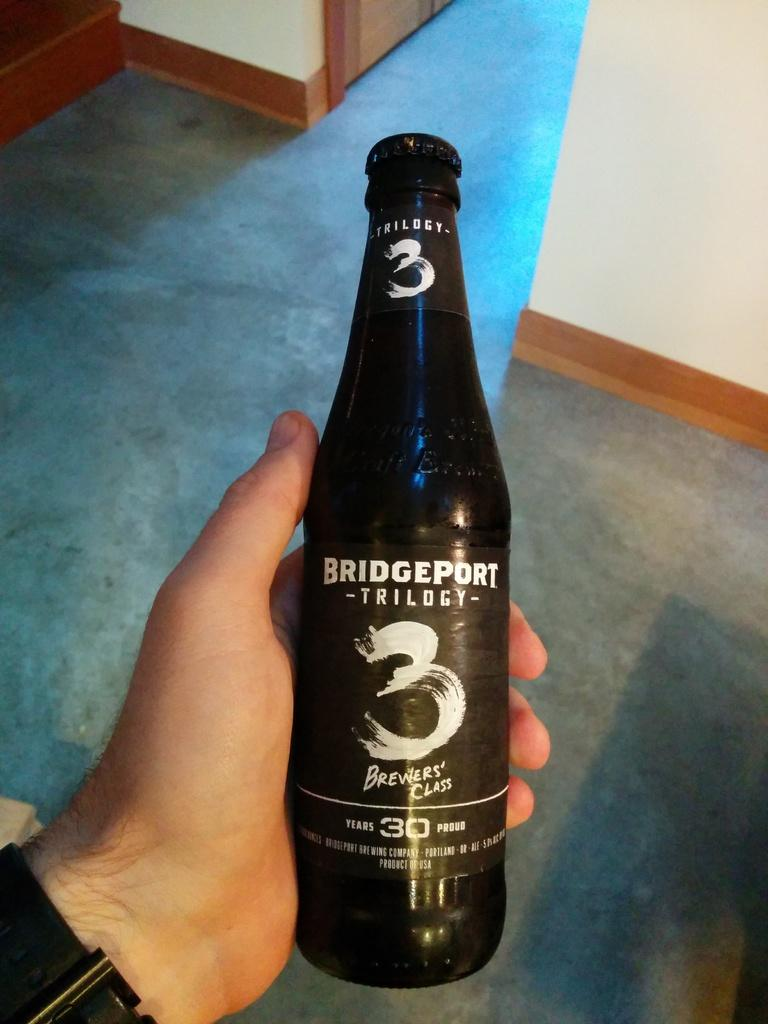<image>
Write a terse but informative summary of the picture. Someone holds a bottle of Bridgeport Trilogy that has the number 3 on it. 